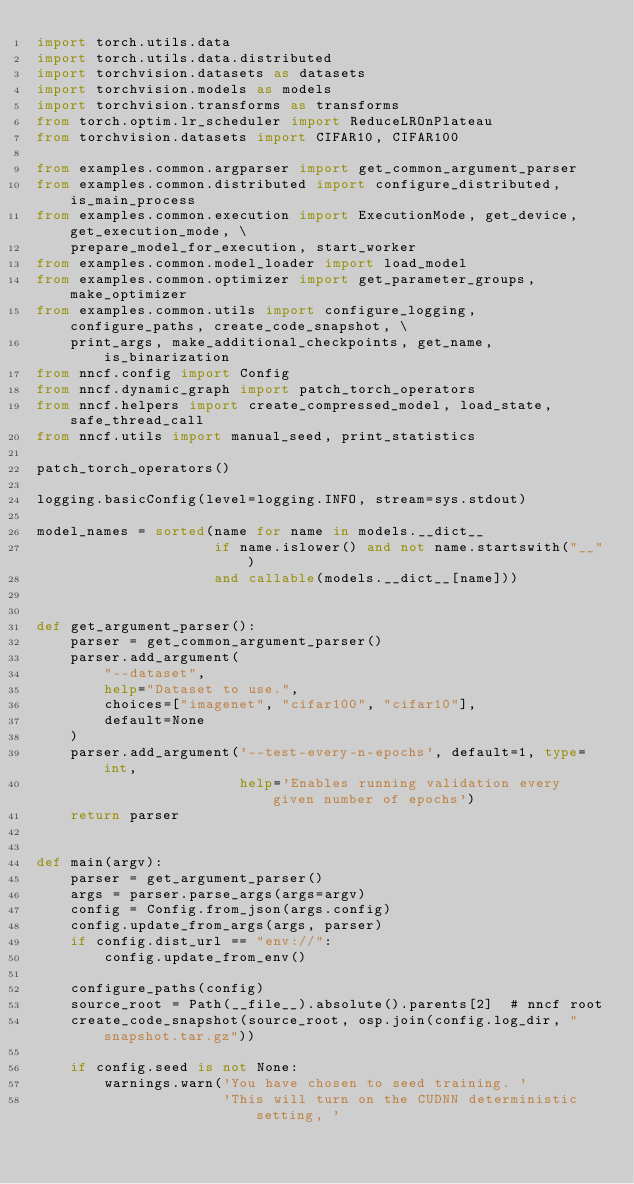Convert code to text. <code><loc_0><loc_0><loc_500><loc_500><_Python_>import torch.utils.data
import torch.utils.data.distributed
import torchvision.datasets as datasets
import torchvision.models as models
import torchvision.transforms as transforms
from torch.optim.lr_scheduler import ReduceLROnPlateau
from torchvision.datasets import CIFAR10, CIFAR100

from examples.common.argparser import get_common_argument_parser
from examples.common.distributed import configure_distributed, is_main_process
from examples.common.execution import ExecutionMode, get_device, get_execution_mode, \
    prepare_model_for_execution, start_worker
from examples.common.model_loader import load_model
from examples.common.optimizer import get_parameter_groups, make_optimizer
from examples.common.utils import configure_logging, configure_paths, create_code_snapshot, \
    print_args, make_additional_checkpoints, get_name, is_binarization
from nncf.config import Config
from nncf.dynamic_graph import patch_torch_operators
from nncf.helpers import create_compressed_model, load_state, safe_thread_call
from nncf.utils import manual_seed, print_statistics

patch_torch_operators()

logging.basicConfig(level=logging.INFO, stream=sys.stdout)

model_names = sorted(name for name in models.__dict__
                     if name.islower() and not name.startswith("__")
                     and callable(models.__dict__[name]))


def get_argument_parser():
    parser = get_common_argument_parser()
    parser.add_argument(
        "--dataset",
        help="Dataset to use.",
        choices=["imagenet", "cifar100", "cifar10"],
        default=None
    )
    parser.add_argument('--test-every-n-epochs', default=1, type=int,
                        help='Enables running validation every given number of epochs')
    return parser


def main(argv):
    parser = get_argument_parser()
    args = parser.parse_args(args=argv)
    config = Config.from_json(args.config)
    config.update_from_args(args, parser)
    if config.dist_url == "env://":
        config.update_from_env()

    configure_paths(config)
    source_root = Path(__file__).absolute().parents[2]  # nncf root
    create_code_snapshot(source_root, osp.join(config.log_dir, "snapshot.tar.gz"))

    if config.seed is not None:
        warnings.warn('You have chosen to seed training. '
                      'This will turn on the CUDNN deterministic setting, '</code> 